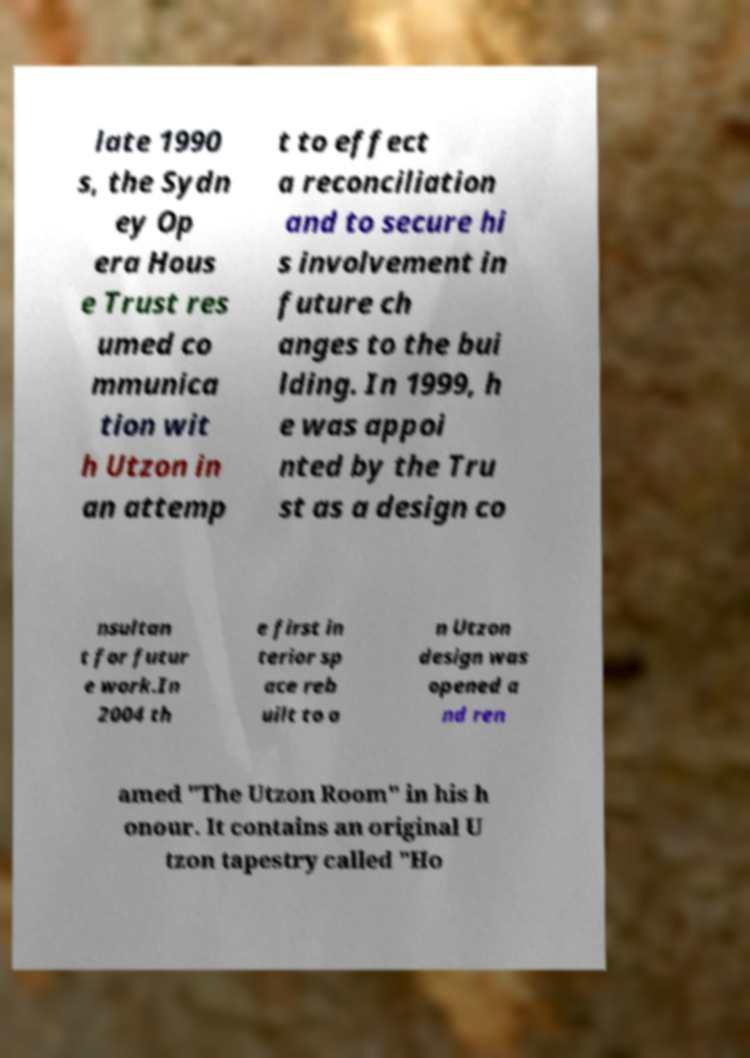Can you read and provide the text displayed in the image?This photo seems to have some interesting text. Can you extract and type it out for me? late 1990 s, the Sydn ey Op era Hous e Trust res umed co mmunica tion wit h Utzon in an attemp t to effect a reconciliation and to secure hi s involvement in future ch anges to the bui lding. In 1999, h e was appoi nted by the Tru st as a design co nsultan t for futur e work.In 2004 th e first in terior sp ace reb uilt to a n Utzon design was opened a nd ren amed "The Utzon Room" in his h onour. It contains an original U tzon tapestry called "Ho 